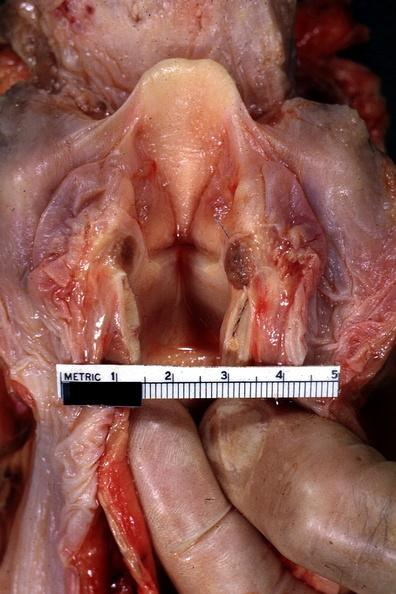where is this?
Answer the question using a single word or phrase. Oral 